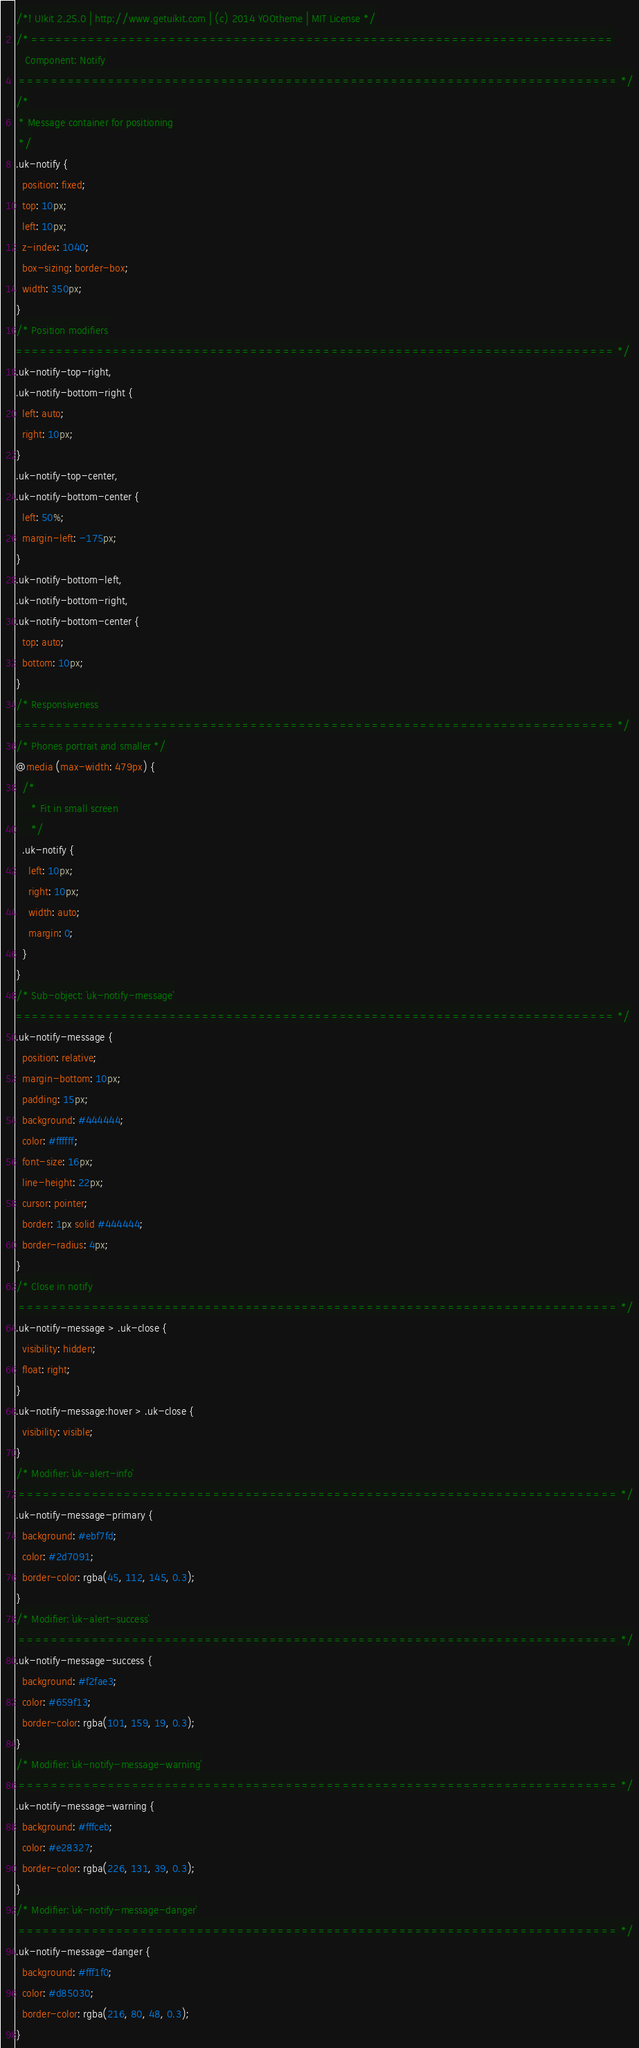<code> <loc_0><loc_0><loc_500><loc_500><_CSS_>/*! UIkit 2.25.0 | http://www.getuikit.com | (c) 2014 YOOtheme | MIT License */
/* ========================================================================
   Component: Notify
 ========================================================================== */
/*
 * Message container for positioning
 */
.uk-notify {
  position: fixed;
  top: 10px;
  left: 10px;
  z-index: 1040;
  box-sizing: border-box;
  width: 350px;
}
/* Position modifiers
========================================================================== */
.uk-notify-top-right,
.uk-notify-bottom-right {
  left: auto;
  right: 10px;
}
.uk-notify-top-center,
.uk-notify-bottom-center {
  left: 50%;
  margin-left: -175px;
}
.uk-notify-bottom-left,
.uk-notify-bottom-right,
.uk-notify-bottom-center {
  top: auto;
  bottom: 10px;
}
/* Responsiveness
========================================================================== */
/* Phones portrait and smaller */
@media (max-width: 479px) {
  /*
     * Fit in small screen
     */
  .uk-notify {
    left: 10px;
    right: 10px;
    width: auto;
    margin: 0;
  }
}
/* Sub-object: `uk-notify-message`
========================================================================== */
.uk-notify-message {
  position: relative;
  margin-bottom: 10px;
  padding: 15px;
  background: #444444;
  color: #ffffff;
  font-size: 16px;
  line-height: 22px;
  cursor: pointer;
  border: 1px solid #444444;
  border-radius: 4px;
}
/* Close in notify
 ========================================================================== */
.uk-notify-message > .uk-close {
  visibility: hidden;
  float: right;
}
.uk-notify-message:hover > .uk-close {
  visibility: visible;
}
/* Modifier: `uk-alert-info`
 ========================================================================== */
.uk-notify-message-primary {
  background: #ebf7fd;
  color: #2d7091;
  border-color: rgba(45, 112, 145, 0.3);
}
/* Modifier: `uk-alert-success`
 ========================================================================== */
.uk-notify-message-success {
  background: #f2fae3;
  color: #659f13;
  border-color: rgba(101, 159, 19, 0.3);
}
/* Modifier: `uk-notify-message-warning`
 ========================================================================== */
.uk-notify-message-warning {
  background: #fffceb;
  color: #e28327;
  border-color: rgba(226, 131, 39, 0.3);
}
/* Modifier: `uk-notify-message-danger`
 ========================================================================== */
.uk-notify-message-danger {
  background: #fff1f0;
  color: #d85030;
  border-color: rgba(216, 80, 48, 0.3);
}
</code> 